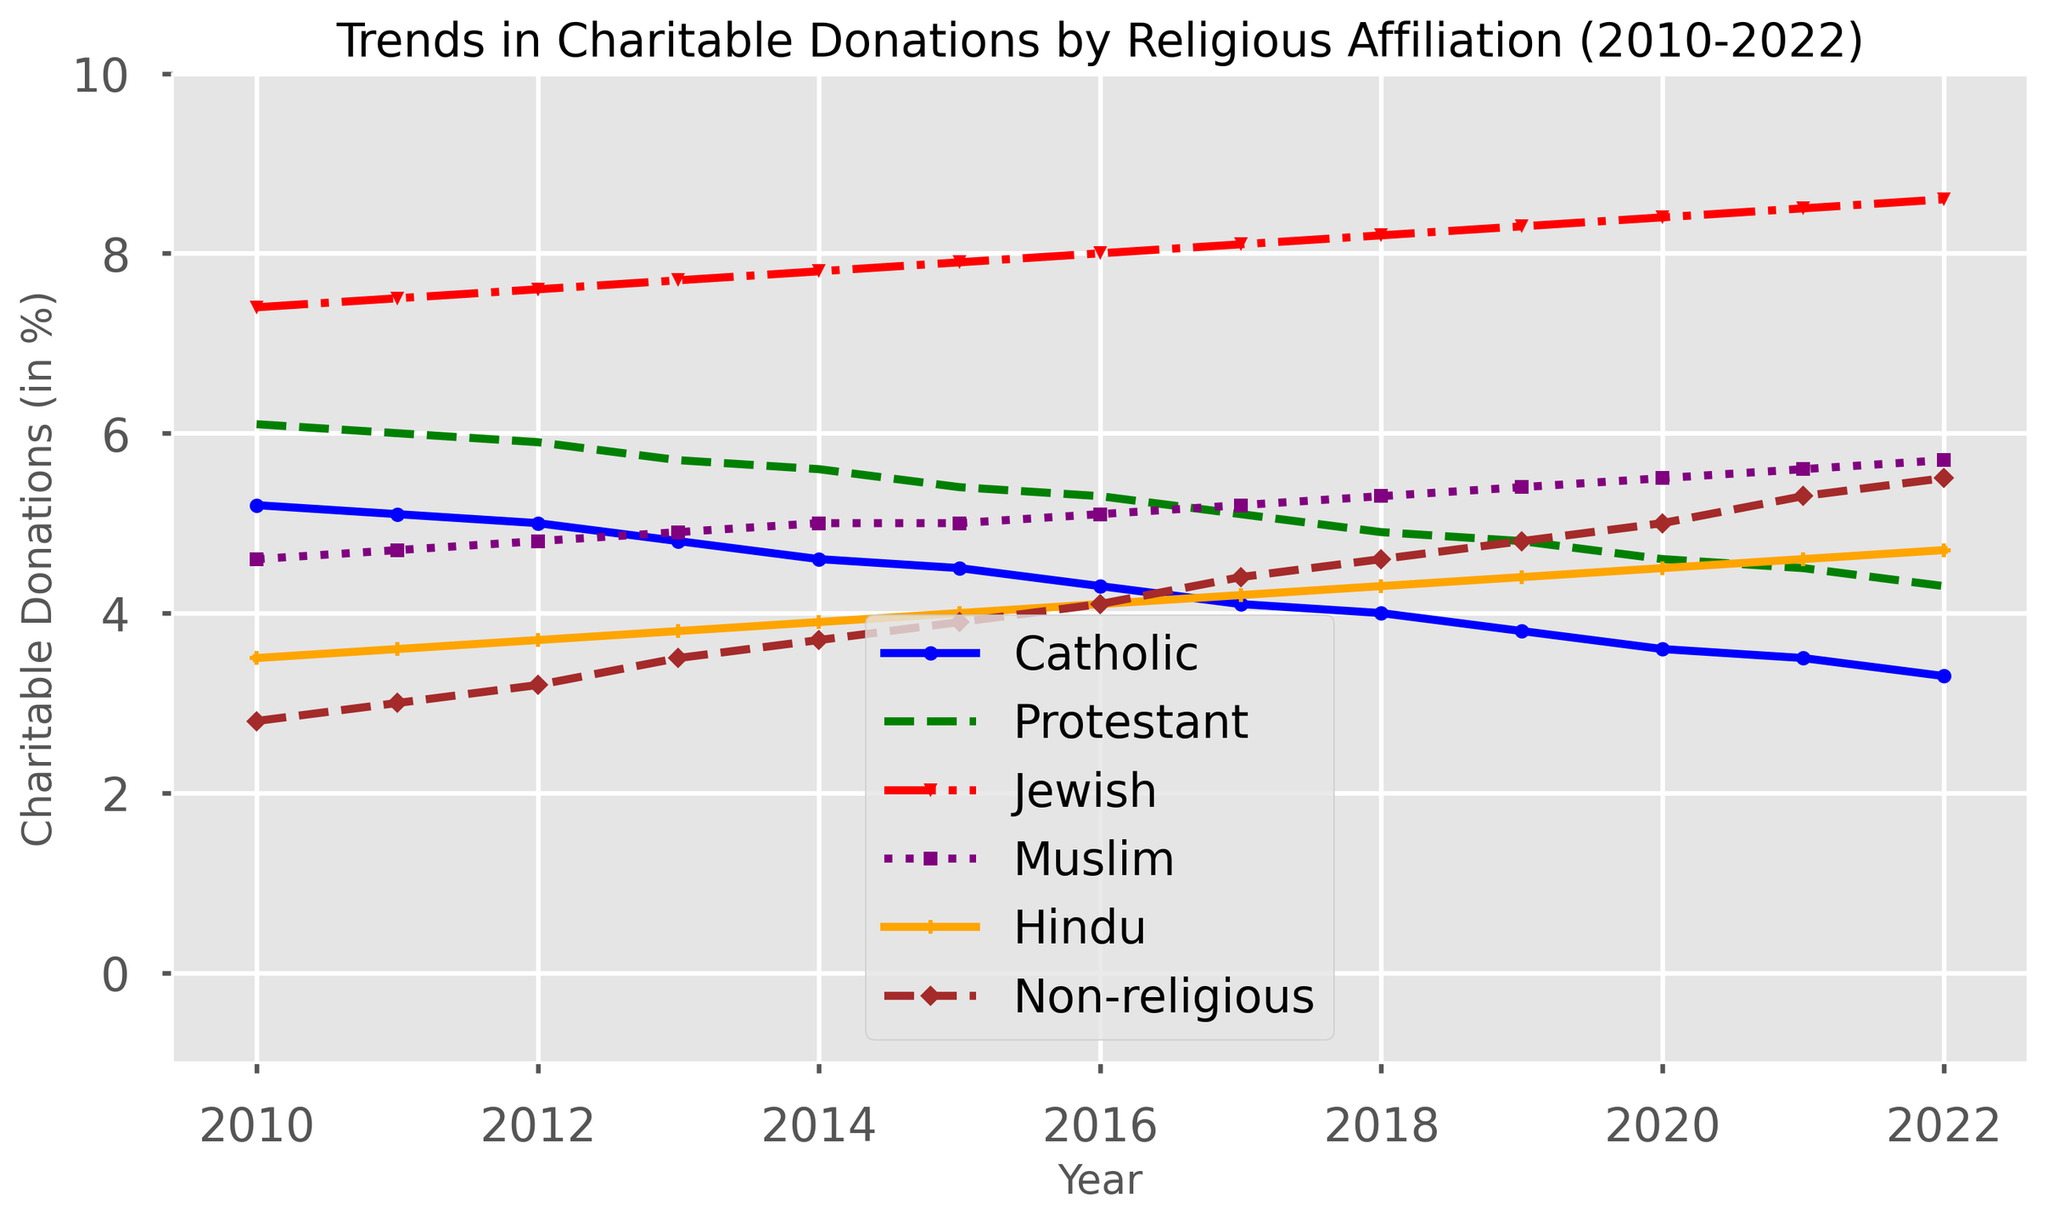what is the trend of charitable donations for Catholics from 2010 to 2022? The trend for Catholics shows a decrease in charitable donations from 5.2% in 2010 to 3.3% in 2022. This indicates a declining trend over the years.
Answer: Decreasing Which group had the highest charitable donations in 2022? In 2022, the Jewish group had the highest charitable donations at 8.6%, which is more than any other group on the plot.
Answer: Jewish How do the charitable donations of Non-religious in 2010 compare to those in 2022? The non-religious charitable donations increased from 2.8% in 2010 to 5.5% in 2022, indicating a significant rise.
Answer: Increased What is the difference in charitable donations between Muslims and Hindus in 2015? In 2015, Muslims had a charitable donation rate of 5.0%, while Hindus had a 4.0%. The difference is 5.0% - 4.0% = 1.0%.
Answer: 1.0% Compare the trend of charitable donations between Protestants and Non-religious from 2010 to 2022. For Protestants, donations decreased from 6.1% in 2010 to 4.3% in 2022. For Non-religious, donations increased from 2.8% to 5.5% over the same period. The trend is opposite; Protestants show a decrease while Non-religious show an increase.
Answer: Opposite trends What year did Jewish charitable donations surpass 8%? Jewish charitable donations surpassed 8% in 2016 with a donation percentage of 8.0%.
Answer: 2016 What is the average charitable donation percentage of Muslims between 2010 and 2015? Sum the percentages for Muslims from 2010 to 2015: 4.6 + 4.7 + 4.8 + 4.9 + 5.0 + 5.0 = 29.0%. There are 6 years, so the average is 29.0/6 = 4.83%.
Answer: 4.83% Which group had the lowest charitable donations in 2014? In 2014, the Hindus had the lowest charitable donations with a percentage of 3.9%, which is less than any other group for that year.
Answer: Hindus By how much did the charitable donations of Catholics decline from 2010 to 2022? The starting value for Catholics in 2010 was 5.2%, and it declined to 3.3% in 2022. The decline is 5.2% - 3.3% = 1.9%.
Answer: 1.9% Which colored line represents the Jewish group on the plot? The Jewish group is represented by the red-colored line on the plot.
Answer: Red 